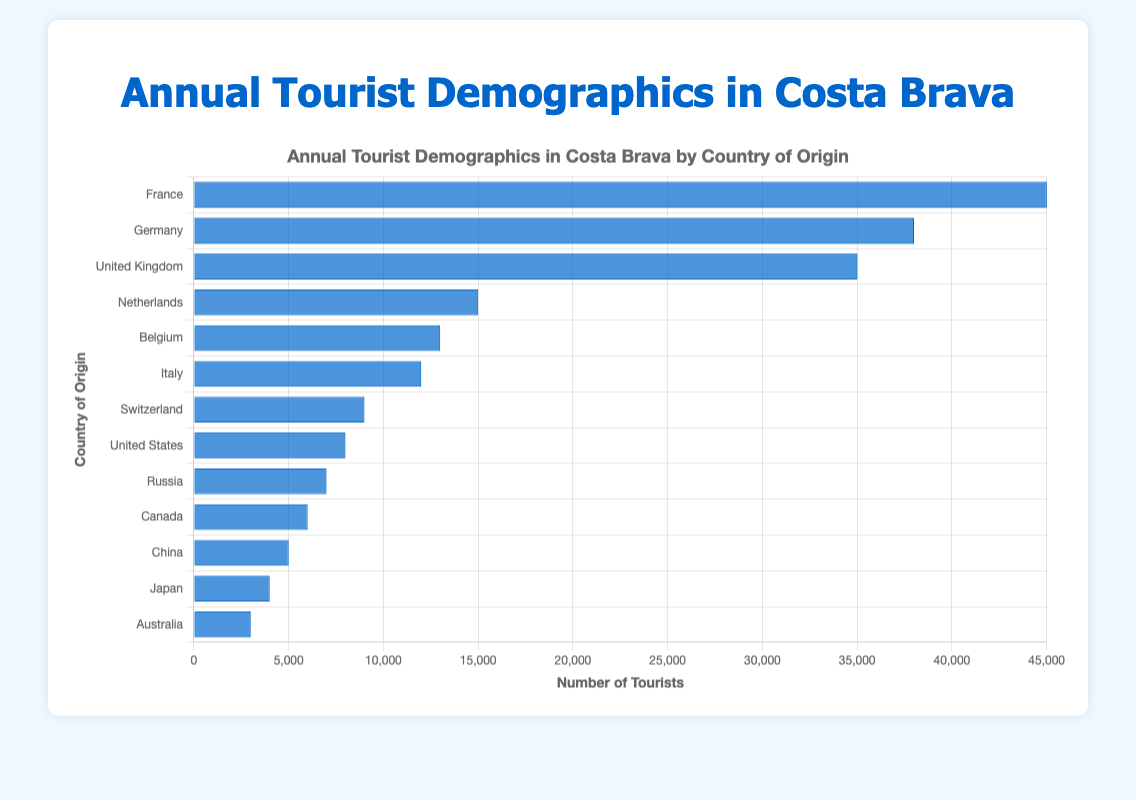Which country has the highest number of tourists visiting Costa Brava? From the bar chart, the tallest bar represents the highest number of tourists, which corresponds to France.
Answer: France How many more tourists come from Germany compared to Belgium? From the figure, Germany has 38,000 tourists and Belgium has 13,000 tourists. The difference is 38,000 - 13,000 = 25,000.
Answer: 25,000 What is the total number of tourists from the United Kingdom and Italy combined? From the figure, the United Kingdom has 35,000 tourists and Italy has 12,000 tourists. Their combined total is 35,000 + 12,000 = 47,000.
Answer: 47,000 Which countries have fewer tourists visiting Costa Brava than Switzerland? From the chart, Switzerland has 9,000 tourists. Countries with fewer tourists than Switzerland are the United States, Russia, Canada, China, Japan, and Australia.
Answer: United States, Russia, Canada, China, Japan, Australia By how much do the tourist numbers from France exceed those from the United Kingdom? From the figure, France has 45,000 tourists and the United Kingdom has 35,000 tourists. The difference is 45,000 - 35,000 = 10,000.
Answer: 10,000 What is the average number of tourists from France, Germany, and the United Kingdom? From the chart, France has 45,000 tourists, Germany has 38,000 tourists, and the United Kingdom has 35,000 tourists. The average is (45,000 + 38,000 + 35,000) / 3 = 118,000 / 3 = 39,333.33.
Answer: 39,333.33 Are there more tourists from China or from Japan? From the chart, the bar representing China is taller than the bar representing Japan, indicating more tourists from China.
Answer: China What is the total number of tourists from all the listed countries? Adding up the number of tourists from all countries: 45,000 (France) + 38,000 (Germany) + 35,000 (United Kingdom) + 15,000 (Netherlands) + 13,000 (Belgium) + 12,000 (Italy) + 9,000 (Switzerland) + 8,000 (United States) + 7,000 (Russia) + 6,000 (Canada) + 5,000 (China) + 4,000 (Japan) + 3,000 (Australia) = 200,000.
Answer: 200,000 